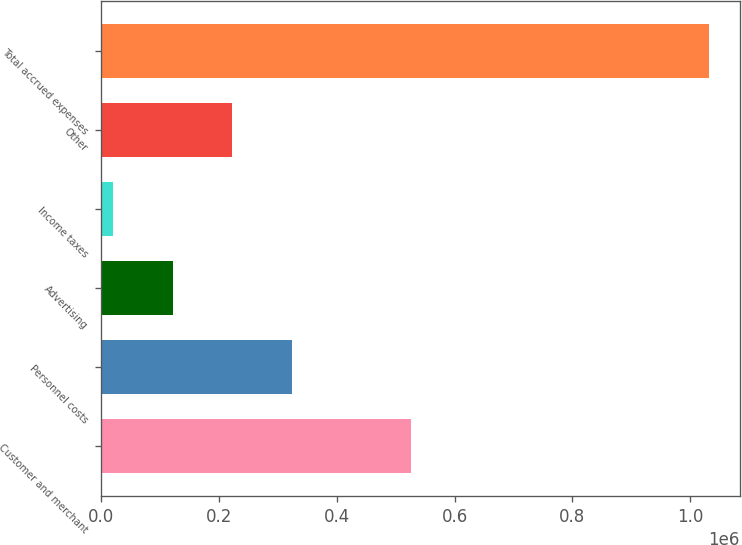<chart> <loc_0><loc_0><loc_500><loc_500><bar_chart><fcel>Customer and merchant<fcel>Personnel costs<fcel>Advertising<fcel>Income taxes<fcel>Other<fcel>Total accrued expenses<nl><fcel>526722<fcel>324098<fcel>121823<fcel>20685<fcel>222960<fcel>1.03206e+06<nl></chart> 